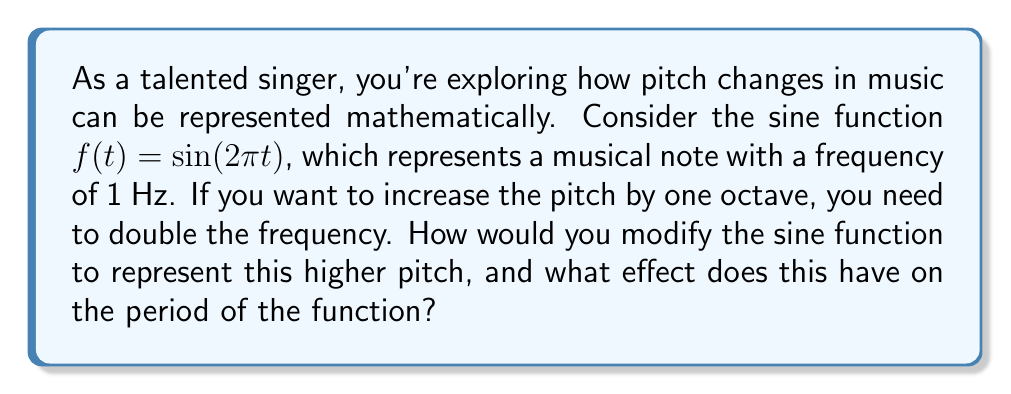Give your solution to this math problem. Let's approach this step-by-step:

1) The original function is $f(t) = \sin(2\pi t)$. This represents a sine wave with a frequency of 1 Hz (one cycle per second).

2) The period of this function is 1 second, which can be calculated using the formula:
   $T = \frac{1}{f} = \frac{1}{1} = 1$ second

3) To increase the pitch by one octave, we need to double the frequency. This means we need to compress the sine wave horizontally so that two cycles fit in the same space where one cycle used to be.

4) Mathematically, this is achieved by multiplying the argument of the sine function by 2:
   $g(t) = \sin(2(2\pi t)) = \sin(4\pi t)$

5) This new function $g(t)$ represents the higher pitch note.

6) To find the new period, we can use the general formula for the period of a sine function:
   $T = \frac{2\pi}{|b|}$, where the function is in the form $\sin(bt)$

7) In our case, $b = 4\pi$, so:
   $T = \frac{2\pi}{|4\pi|} = \frac{1}{2}$ second

8) This confirms that the period has been halved, which corresponds to doubling the frequency.

The effect of this transformation is to compress the sine wave horizontally, resulting in a higher frequency (pitch) and a shorter period.
Answer: The function representing the higher pitch (one octave above) is $g(t) = \sin(4\pi t)$. This transformation halves the period of the function from 1 second to $\frac{1}{2}$ second. 